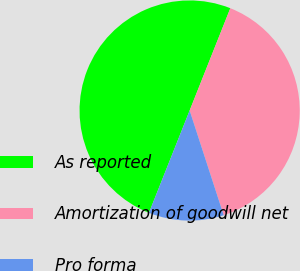Convert chart. <chart><loc_0><loc_0><loc_500><loc_500><pie_chart><fcel>As reported<fcel>Amortization of goodwill net<fcel>Pro forma<nl><fcel>50.0%<fcel>38.97%<fcel>11.03%<nl></chart> 